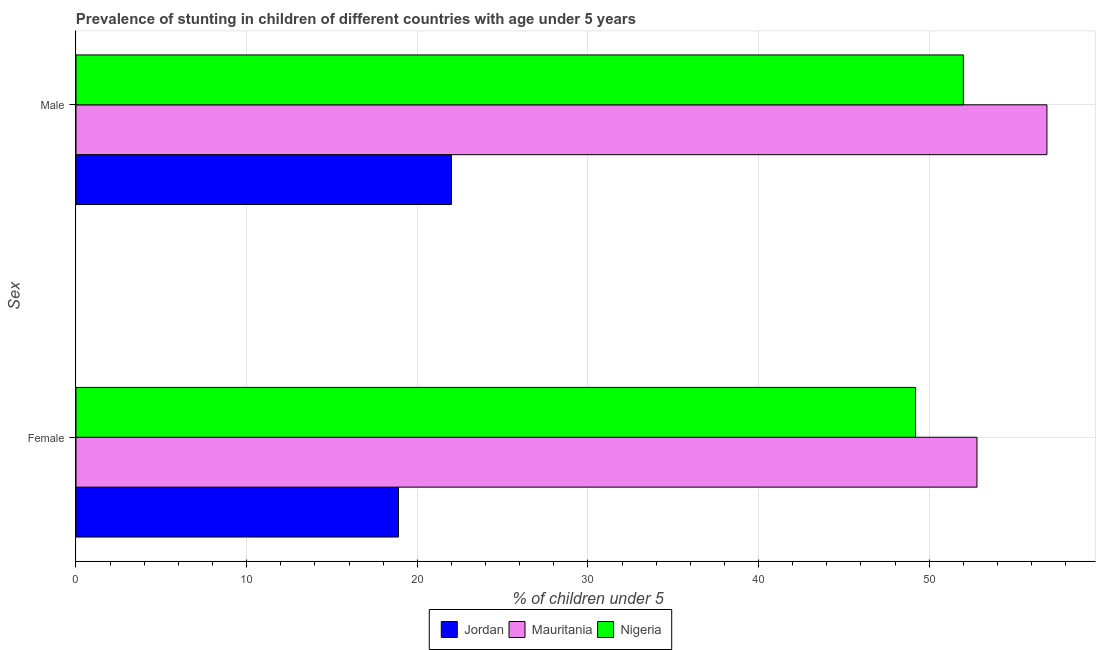How many groups of bars are there?
Offer a terse response. 2. Are the number of bars per tick equal to the number of legend labels?
Offer a terse response. Yes. How many bars are there on the 1st tick from the bottom?
Your response must be concise. 3. What is the percentage of stunted female children in Jordan?
Your answer should be compact. 18.9. Across all countries, what is the maximum percentage of stunted male children?
Provide a short and direct response. 56.9. Across all countries, what is the minimum percentage of stunted female children?
Your answer should be very brief. 18.9. In which country was the percentage of stunted female children maximum?
Offer a very short reply. Mauritania. In which country was the percentage of stunted female children minimum?
Give a very brief answer. Jordan. What is the total percentage of stunted male children in the graph?
Make the answer very short. 130.9. What is the difference between the percentage of stunted male children in Jordan and that in Nigeria?
Keep it short and to the point. -30. What is the difference between the percentage of stunted female children in Jordan and the percentage of stunted male children in Mauritania?
Offer a very short reply. -38. What is the average percentage of stunted male children per country?
Your answer should be compact. 43.63. What is the difference between the percentage of stunted male children and percentage of stunted female children in Nigeria?
Keep it short and to the point. 2.8. What is the ratio of the percentage of stunted female children in Mauritania to that in Nigeria?
Ensure brevity in your answer.  1.07. Is the percentage of stunted male children in Jordan less than that in Mauritania?
Offer a terse response. Yes. What does the 2nd bar from the top in Male represents?
Your response must be concise. Mauritania. What does the 2nd bar from the bottom in Male represents?
Your answer should be very brief. Mauritania. How many bars are there?
Offer a terse response. 6. Are all the bars in the graph horizontal?
Your answer should be compact. Yes. How many countries are there in the graph?
Keep it short and to the point. 3. What is the difference between two consecutive major ticks on the X-axis?
Your answer should be compact. 10. Does the graph contain any zero values?
Ensure brevity in your answer.  No. How many legend labels are there?
Ensure brevity in your answer.  3. What is the title of the graph?
Offer a terse response. Prevalence of stunting in children of different countries with age under 5 years. What is the label or title of the X-axis?
Keep it short and to the point.  % of children under 5. What is the label or title of the Y-axis?
Your answer should be compact. Sex. What is the  % of children under 5 of Jordan in Female?
Offer a terse response. 18.9. What is the  % of children under 5 of Mauritania in Female?
Keep it short and to the point. 52.8. What is the  % of children under 5 in Nigeria in Female?
Your response must be concise. 49.2. What is the  % of children under 5 in Jordan in Male?
Provide a short and direct response. 22. What is the  % of children under 5 in Mauritania in Male?
Ensure brevity in your answer.  56.9. What is the  % of children under 5 in Nigeria in Male?
Your answer should be compact. 52. Across all Sex, what is the maximum  % of children under 5 in Mauritania?
Provide a short and direct response. 56.9. Across all Sex, what is the minimum  % of children under 5 of Jordan?
Give a very brief answer. 18.9. Across all Sex, what is the minimum  % of children under 5 of Mauritania?
Provide a short and direct response. 52.8. Across all Sex, what is the minimum  % of children under 5 in Nigeria?
Keep it short and to the point. 49.2. What is the total  % of children under 5 of Jordan in the graph?
Provide a short and direct response. 40.9. What is the total  % of children under 5 of Mauritania in the graph?
Your answer should be very brief. 109.7. What is the total  % of children under 5 in Nigeria in the graph?
Your response must be concise. 101.2. What is the difference between the  % of children under 5 of Mauritania in Female and that in Male?
Give a very brief answer. -4.1. What is the difference between the  % of children under 5 of Jordan in Female and the  % of children under 5 of Mauritania in Male?
Give a very brief answer. -38. What is the difference between the  % of children under 5 in Jordan in Female and the  % of children under 5 in Nigeria in Male?
Your response must be concise. -33.1. What is the average  % of children under 5 of Jordan per Sex?
Ensure brevity in your answer.  20.45. What is the average  % of children under 5 in Mauritania per Sex?
Offer a very short reply. 54.85. What is the average  % of children under 5 of Nigeria per Sex?
Keep it short and to the point. 50.6. What is the difference between the  % of children under 5 of Jordan and  % of children under 5 of Mauritania in Female?
Give a very brief answer. -33.9. What is the difference between the  % of children under 5 in Jordan and  % of children under 5 in Nigeria in Female?
Offer a terse response. -30.3. What is the difference between the  % of children under 5 in Mauritania and  % of children under 5 in Nigeria in Female?
Your answer should be compact. 3.6. What is the difference between the  % of children under 5 of Jordan and  % of children under 5 of Mauritania in Male?
Offer a terse response. -34.9. What is the difference between the  % of children under 5 in Jordan and  % of children under 5 in Nigeria in Male?
Provide a short and direct response. -30. What is the difference between the  % of children under 5 in Mauritania and  % of children under 5 in Nigeria in Male?
Your answer should be compact. 4.9. What is the ratio of the  % of children under 5 in Jordan in Female to that in Male?
Offer a very short reply. 0.86. What is the ratio of the  % of children under 5 in Mauritania in Female to that in Male?
Your response must be concise. 0.93. What is the ratio of the  % of children under 5 of Nigeria in Female to that in Male?
Keep it short and to the point. 0.95. What is the difference between the highest and the second highest  % of children under 5 of Jordan?
Provide a short and direct response. 3.1. What is the difference between the highest and the second highest  % of children under 5 of Mauritania?
Provide a short and direct response. 4.1. What is the difference between the highest and the lowest  % of children under 5 of Jordan?
Your response must be concise. 3.1. What is the difference between the highest and the lowest  % of children under 5 in Mauritania?
Make the answer very short. 4.1. 